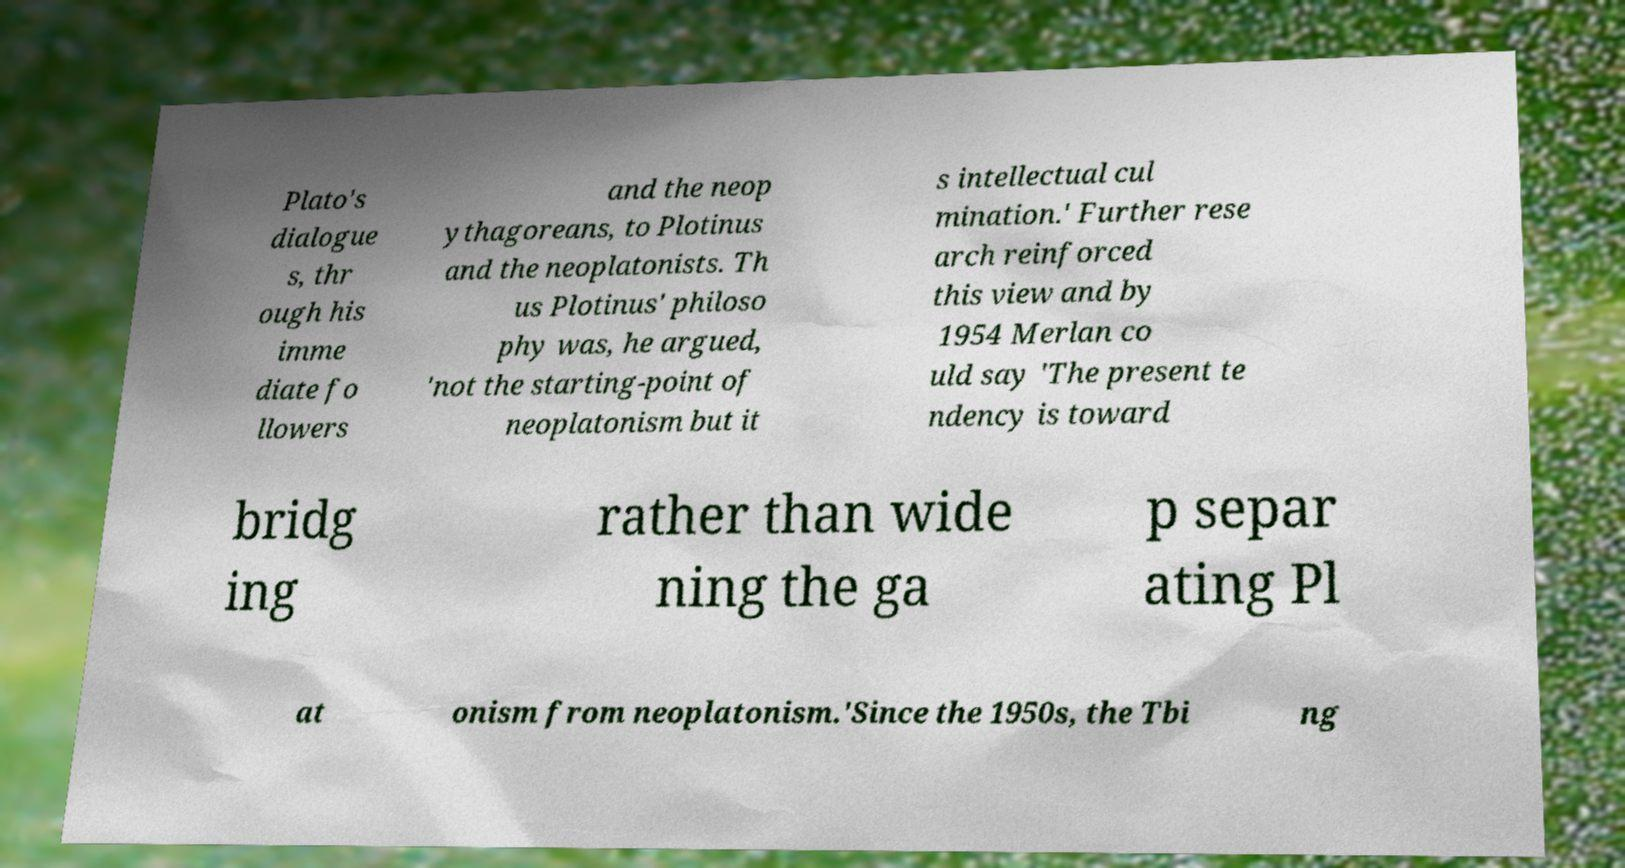Please identify and transcribe the text found in this image. Plato's dialogue s, thr ough his imme diate fo llowers and the neop ythagoreans, to Plotinus and the neoplatonists. Th us Plotinus' philoso phy was, he argued, 'not the starting-point of neoplatonism but it s intellectual cul mination.' Further rese arch reinforced this view and by 1954 Merlan co uld say 'The present te ndency is toward bridg ing rather than wide ning the ga p separ ating Pl at onism from neoplatonism.'Since the 1950s, the Tbi ng 